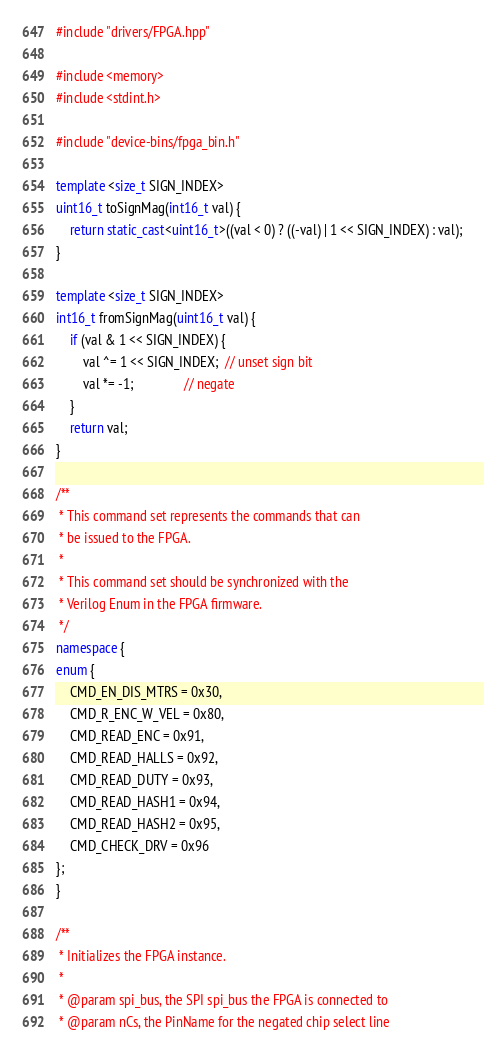Convert code to text. <code><loc_0><loc_0><loc_500><loc_500><_C++_>#include "drivers/FPGA.hpp"

#include <memory>
#include <stdint.h>

#include "device-bins/fpga_bin.h"

template <size_t SIGN_INDEX>
uint16_t toSignMag(int16_t val) {
    return static_cast<uint16_t>((val < 0) ? ((-val) | 1 << SIGN_INDEX) : val);
}

template <size_t SIGN_INDEX>
int16_t fromSignMag(uint16_t val) {
    if (val & 1 << SIGN_INDEX) {
        val ^= 1 << SIGN_INDEX;  // unset sign bit
        val *= -1;               // negate
    }
    return val;
}

/**
 * This command set represents the commands that can
 * be issued to the FPGA.
 *
 * This command set should be synchronized with the
 * Verilog Enum in the FPGA firmware.
 */
namespace {
enum {
    CMD_EN_DIS_MTRS = 0x30,
    CMD_R_ENC_W_VEL = 0x80,
    CMD_READ_ENC = 0x91,
    CMD_READ_HALLS = 0x92,
    CMD_READ_DUTY = 0x93,
    CMD_READ_HASH1 = 0x94,
    CMD_READ_HASH2 = 0x95,
    CMD_CHECK_DRV = 0x96
};
}

/**
 * Initializes the FPGA instance.
 *
 * @param spi_bus, the SPI spi_bus the FPGA is connected to
 * @param nCs, the PinName for the negated chip select line</code> 